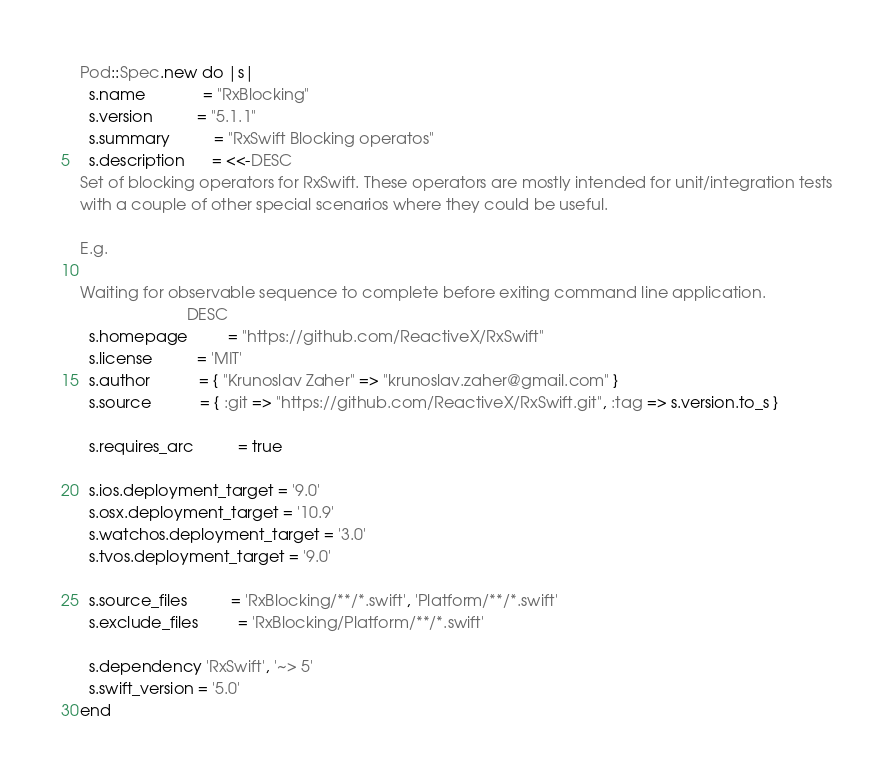Convert code to text. <code><loc_0><loc_0><loc_500><loc_500><_Ruby_>Pod::Spec.new do |s|
  s.name             = "RxBlocking"
  s.version          = "5.1.1"
  s.summary          = "RxSwift Blocking operatos"
  s.description      = <<-DESC
Set of blocking operators for RxSwift. These operators are mostly intended for unit/integration tests
with a couple of other special scenarios where they could be useful.

E.g.

Waiting for observable sequence to complete before exiting command line application.
                        DESC
  s.homepage         = "https://github.com/ReactiveX/RxSwift"
  s.license          = 'MIT'
  s.author           = { "Krunoslav Zaher" => "krunoslav.zaher@gmail.com" }
  s.source           = { :git => "https://github.com/ReactiveX/RxSwift.git", :tag => s.version.to_s }

  s.requires_arc          = true

  s.ios.deployment_target = '9.0'
  s.osx.deployment_target = '10.9'
  s.watchos.deployment_target = '3.0'
  s.tvos.deployment_target = '9.0'

  s.source_files          = 'RxBlocking/**/*.swift', 'Platform/**/*.swift'
  s.exclude_files         = 'RxBlocking/Platform/**/*.swift'

  s.dependency 'RxSwift', '~> 5'
  s.swift_version = '5.0'
end
</code> 